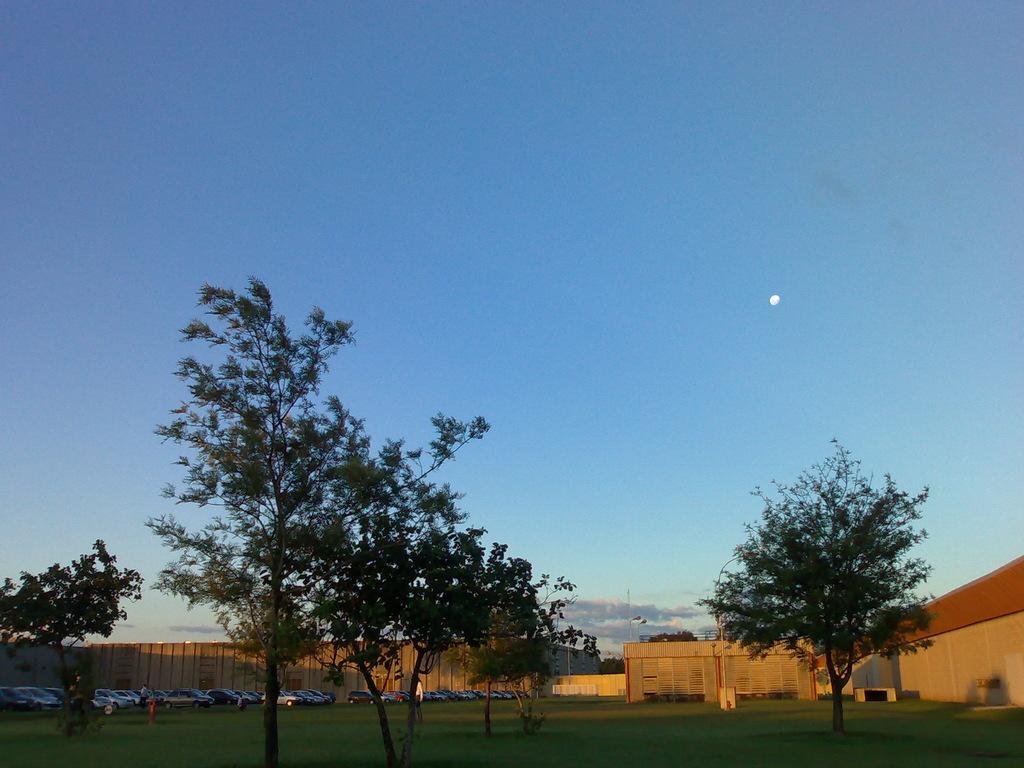How would you summarize this image in a sentence or two? In this image I can see trees and few cars. Back Side I can see building. The sky is in blue and white color. 